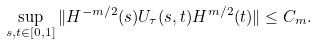Convert formula to latex. <formula><loc_0><loc_0><loc_500><loc_500>\sup _ { s , t \in [ 0 , 1 ] } \| H ^ { - m / 2 } ( s ) U _ { \tau } ( s , t ) H ^ { m / 2 } ( t ) \| \leq C _ { m } .</formula> 